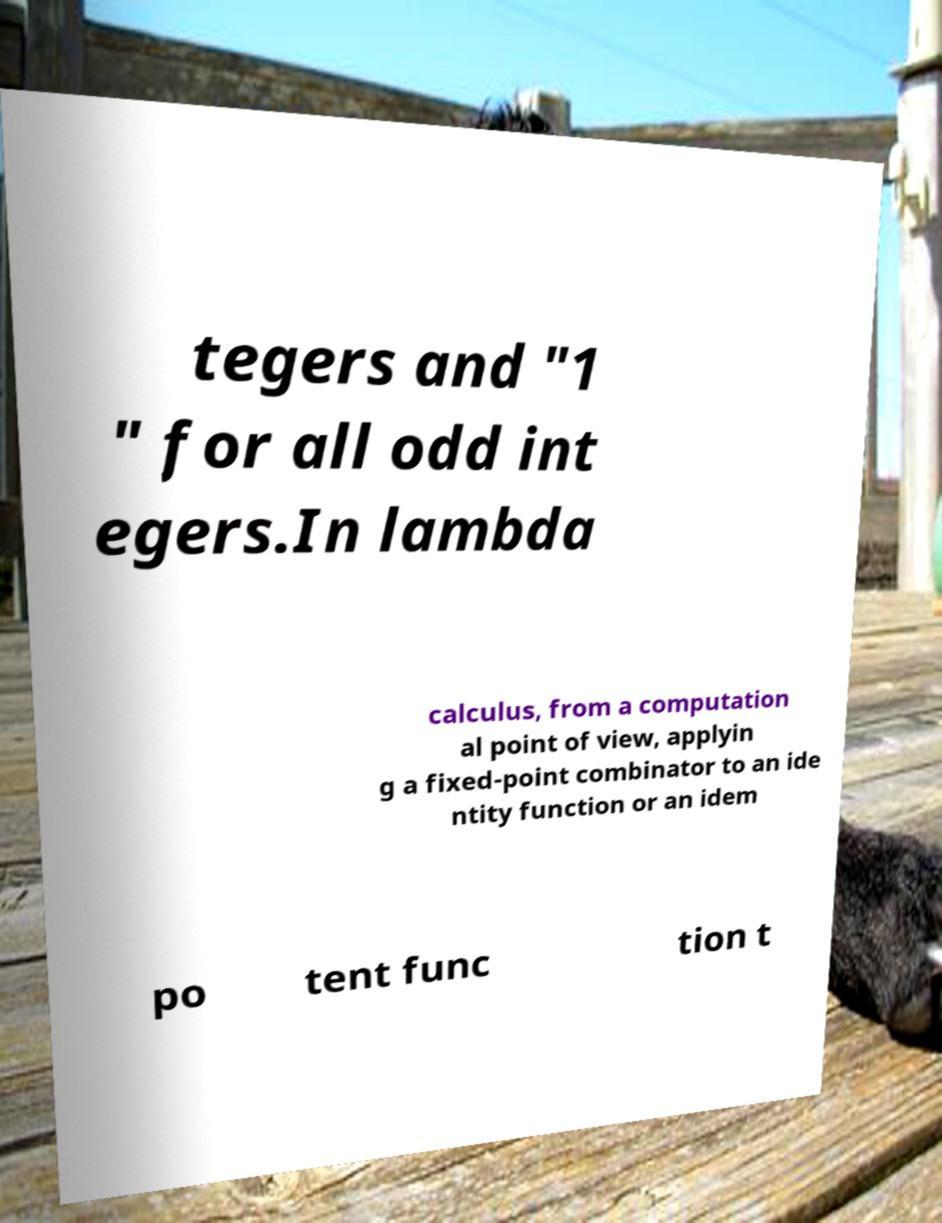Can you read and provide the text displayed in the image?This photo seems to have some interesting text. Can you extract and type it out for me? tegers and "1 " for all odd int egers.In lambda calculus, from a computation al point of view, applyin g a fixed-point combinator to an ide ntity function or an idem po tent func tion t 